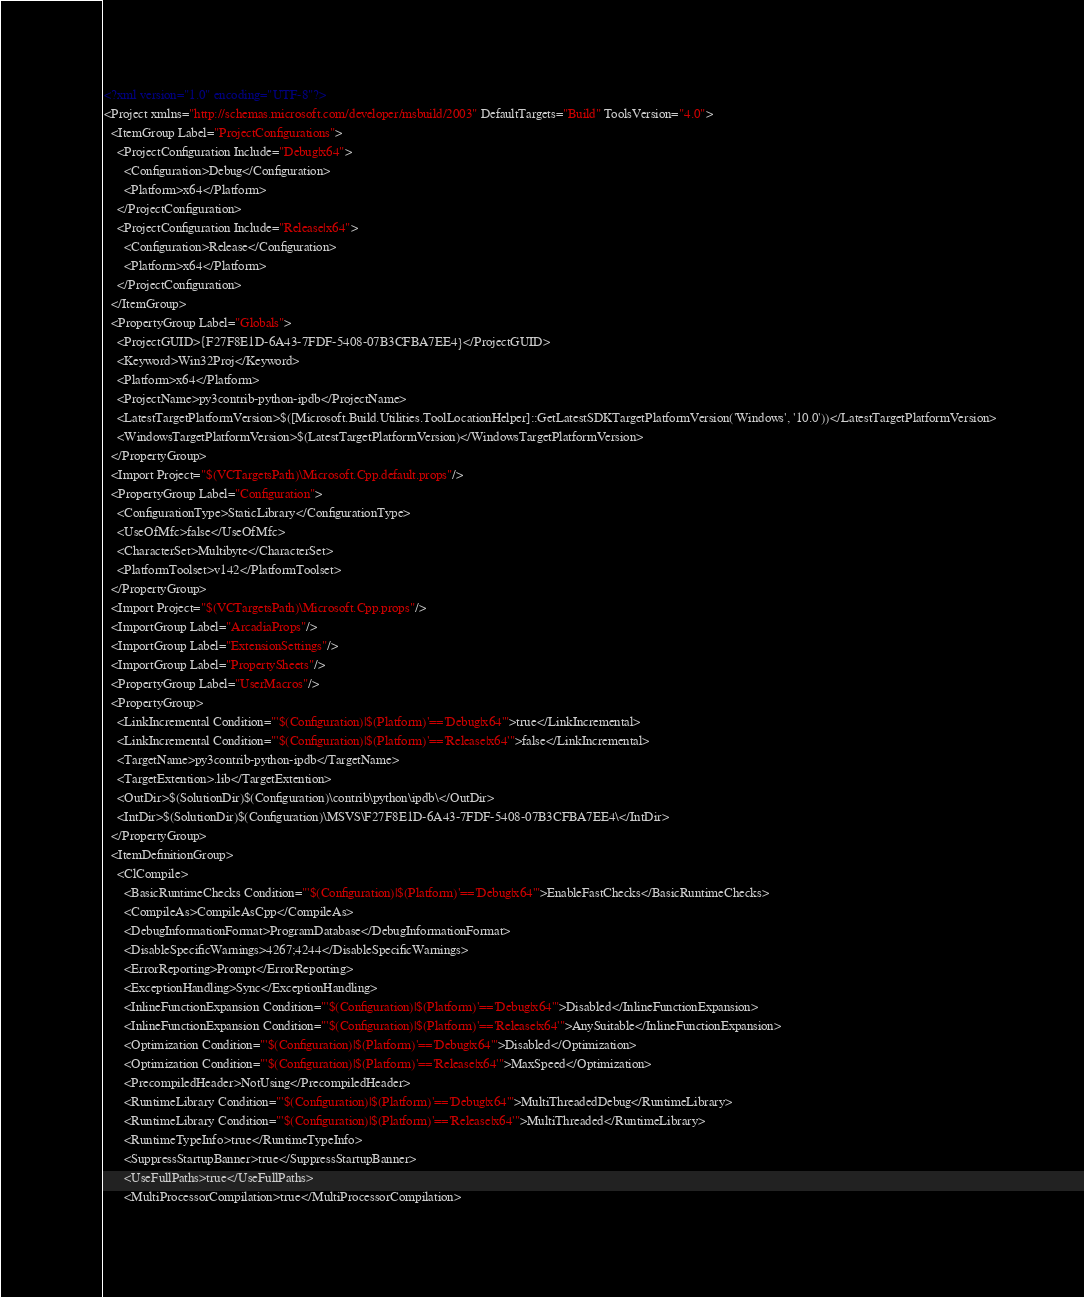Convert code to text. <code><loc_0><loc_0><loc_500><loc_500><_XML_><?xml version="1.0" encoding="UTF-8"?>
<Project xmlns="http://schemas.microsoft.com/developer/msbuild/2003" DefaultTargets="Build" ToolsVersion="4.0">
  <ItemGroup Label="ProjectConfigurations">
    <ProjectConfiguration Include="Debug|x64">
      <Configuration>Debug</Configuration>
      <Platform>x64</Platform>
    </ProjectConfiguration>
    <ProjectConfiguration Include="Release|x64">
      <Configuration>Release</Configuration>
      <Platform>x64</Platform>
    </ProjectConfiguration>
  </ItemGroup>
  <PropertyGroup Label="Globals">
    <ProjectGUID>{F27F8E1D-6A43-7FDF-5408-07B3CFBA7EE4}</ProjectGUID>
    <Keyword>Win32Proj</Keyword>
    <Platform>x64</Platform>
    <ProjectName>py3contrib-python-ipdb</ProjectName>
    <LatestTargetPlatformVersion>$([Microsoft.Build.Utilities.ToolLocationHelper]::GetLatestSDKTargetPlatformVersion('Windows', '10.0'))</LatestTargetPlatformVersion>
    <WindowsTargetPlatformVersion>$(LatestTargetPlatformVersion)</WindowsTargetPlatformVersion>
  </PropertyGroup>
  <Import Project="$(VCTargetsPath)\Microsoft.Cpp.default.props"/>
  <PropertyGroup Label="Configuration">
    <ConfigurationType>StaticLibrary</ConfigurationType>
    <UseOfMfc>false</UseOfMfc>
    <CharacterSet>Multibyte</CharacterSet>
    <PlatformToolset>v142</PlatformToolset>
  </PropertyGroup>
  <Import Project="$(VCTargetsPath)\Microsoft.Cpp.props"/>
  <ImportGroup Label="ArcadiaProps"/>
  <ImportGroup Label="ExtensionSettings"/>
  <ImportGroup Label="PropertySheets"/>
  <PropertyGroup Label="UserMacros"/>
  <PropertyGroup>
    <LinkIncremental Condition="'$(Configuration)|$(Platform)'=='Debug|x64'">true</LinkIncremental>
    <LinkIncremental Condition="'$(Configuration)|$(Platform)'=='Release|x64'">false</LinkIncremental>
    <TargetName>py3contrib-python-ipdb</TargetName>
    <TargetExtention>.lib</TargetExtention>
    <OutDir>$(SolutionDir)$(Configuration)\contrib\python\ipdb\</OutDir>
    <IntDir>$(SolutionDir)$(Configuration)\MSVS\F27F8E1D-6A43-7FDF-5408-07B3CFBA7EE4\</IntDir>
  </PropertyGroup>
  <ItemDefinitionGroup>
    <ClCompile>
      <BasicRuntimeChecks Condition="'$(Configuration)|$(Platform)'=='Debug|x64'">EnableFastChecks</BasicRuntimeChecks>
      <CompileAs>CompileAsCpp</CompileAs>
      <DebugInformationFormat>ProgramDatabase</DebugInformationFormat>
      <DisableSpecificWarnings>4267;4244</DisableSpecificWarnings>
      <ErrorReporting>Prompt</ErrorReporting>
      <ExceptionHandling>Sync</ExceptionHandling>
      <InlineFunctionExpansion Condition="'$(Configuration)|$(Platform)'=='Debug|x64'">Disabled</InlineFunctionExpansion>
      <InlineFunctionExpansion Condition="'$(Configuration)|$(Platform)'=='Release|x64'">AnySuitable</InlineFunctionExpansion>
      <Optimization Condition="'$(Configuration)|$(Platform)'=='Debug|x64'">Disabled</Optimization>
      <Optimization Condition="'$(Configuration)|$(Platform)'=='Release|x64'">MaxSpeed</Optimization>
      <PrecompiledHeader>NotUsing</PrecompiledHeader>
      <RuntimeLibrary Condition="'$(Configuration)|$(Platform)'=='Debug|x64'">MultiThreadedDebug</RuntimeLibrary>
      <RuntimeLibrary Condition="'$(Configuration)|$(Platform)'=='Release|x64'">MultiThreaded</RuntimeLibrary>
      <RuntimeTypeInfo>true</RuntimeTypeInfo>
      <SuppressStartupBanner>true</SuppressStartupBanner>
      <UseFullPaths>true</UseFullPaths>
      <MultiProcessorCompilation>true</MultiProcessorCompilation></code> 